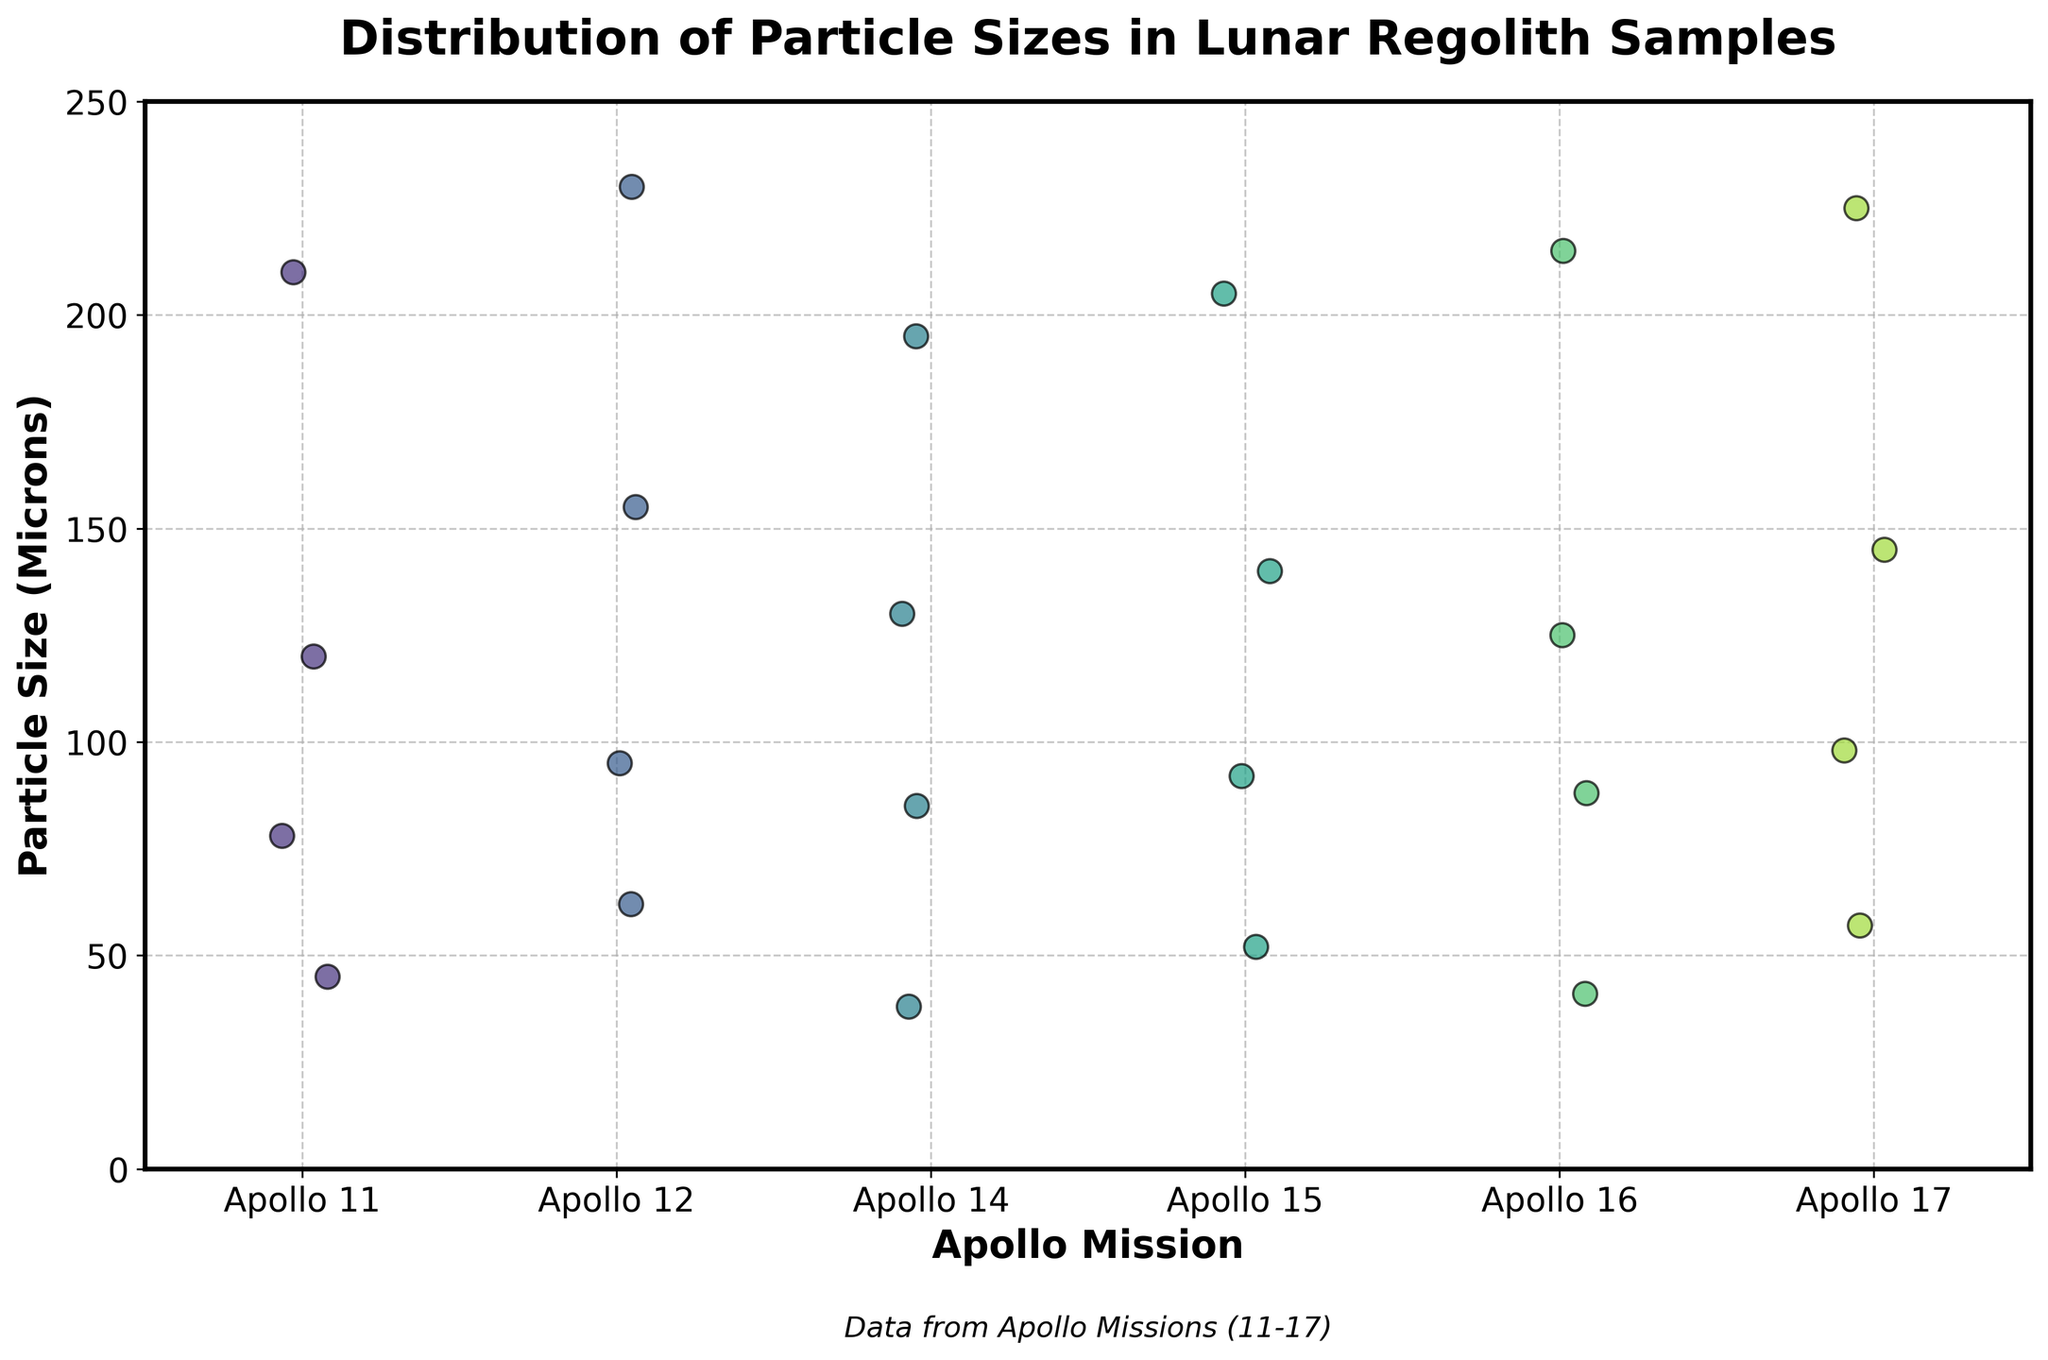What's the title of the plot? The title of the plot is found at the top of the figure. It reads "Distribution of Particle Sizes in Lunar Regolith Samples".
Answer: Distribution of Particle Sizes in Lunar Regolith Samples Which Apollo mission has the largest recorded particle size? By looking at the strip plot, Apollo 17 has the largest recorded particle size, which is 225 microns.
Answer: Apollo 17 What is the range of particle sizes for Apollo 14? To find the range, identify the smallest and largest values on the y-axis for Apollo 14. The smallest is 38 microns and the largest is 195 microns, so the range is 195 - 38 = 157 microns.
Answer: 157 microns How many data points are there for each mission? By visually counting the dots (data points) in each strip for every mission on the x-axis, each mission (Apollo 11 to Apollo 17) has 4 data points.
Answer: 4 Which mission has the smallest median particle size? To find the median, look at the middle value of ordered data points in each strip. Apollo 11's median is ~99 microns, Apollo 12's is ~108 microns, Apollo 14's is ~107.5 microns, Apollo 15's is ~116 microns, Apollo 16's is ~106.5 microns, and Apollo 17's is ~121.5 microns. Thus, Apollo 11 has the smallest median.
Answer: Apollo 11 What's the difference between the largest particle size in Apollo 11 and Apollo 16? Identify the largest particle size for both missions: 210 microns for Apollo 11 and 215 microns for Apollo 16. The difference is 215 - 210 = 5 microns.
Answer: 5 microns Which mission shows the widest distribution of particle sizes? By comparing the spread of dots for each mission, Apollo 17 has the widest distribution with sizes ranging from 57 to 225 microns.
Answer: Apollo 17 Are there any overlapping particle sizes between Apollo 12 and Apollo 15? Visually compare the two strips; Apollo 12 has particle sizes of 62, 95, 155, 230 microns, and Apollo 15 has 52, 92, 140, 205 microns. There are no overlapping sizes.
Answer: No What's the average particle size for Apollo 12? Sum the particle sizes for Apollo 12 (62 + 95 + 155 + 230 = 542) and divide by the number of data points (4). The average is 542 / 4 = 135.5 microns.
Answer: 135.5 microns 